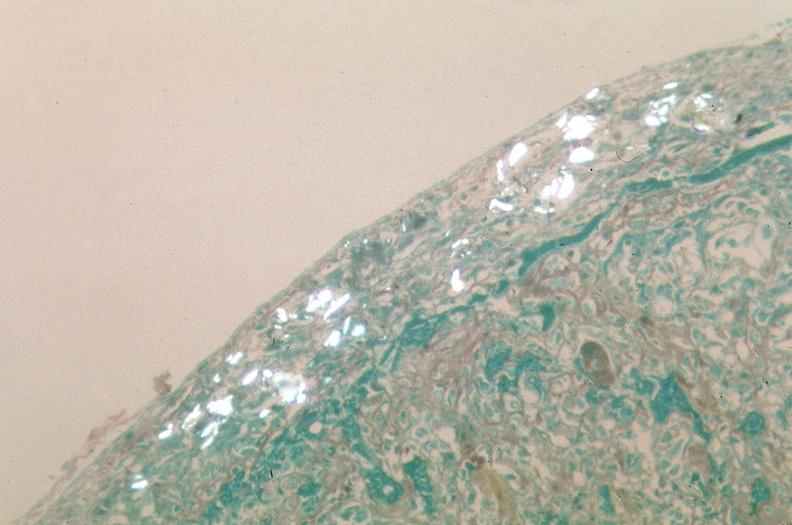what does this image show?
Answer the question using a single word or phrase. Pleura 